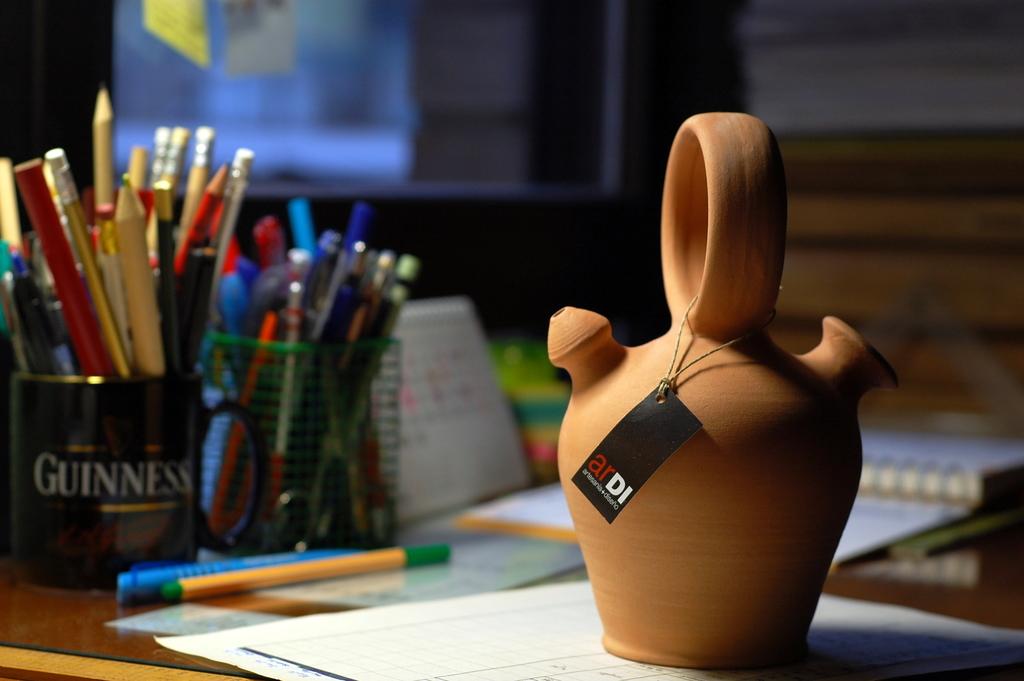Who made the ceramic tea kettle?
Provide a short and direct response. Ardi. What is on the mug?
Your response must be concise. Ardi. 